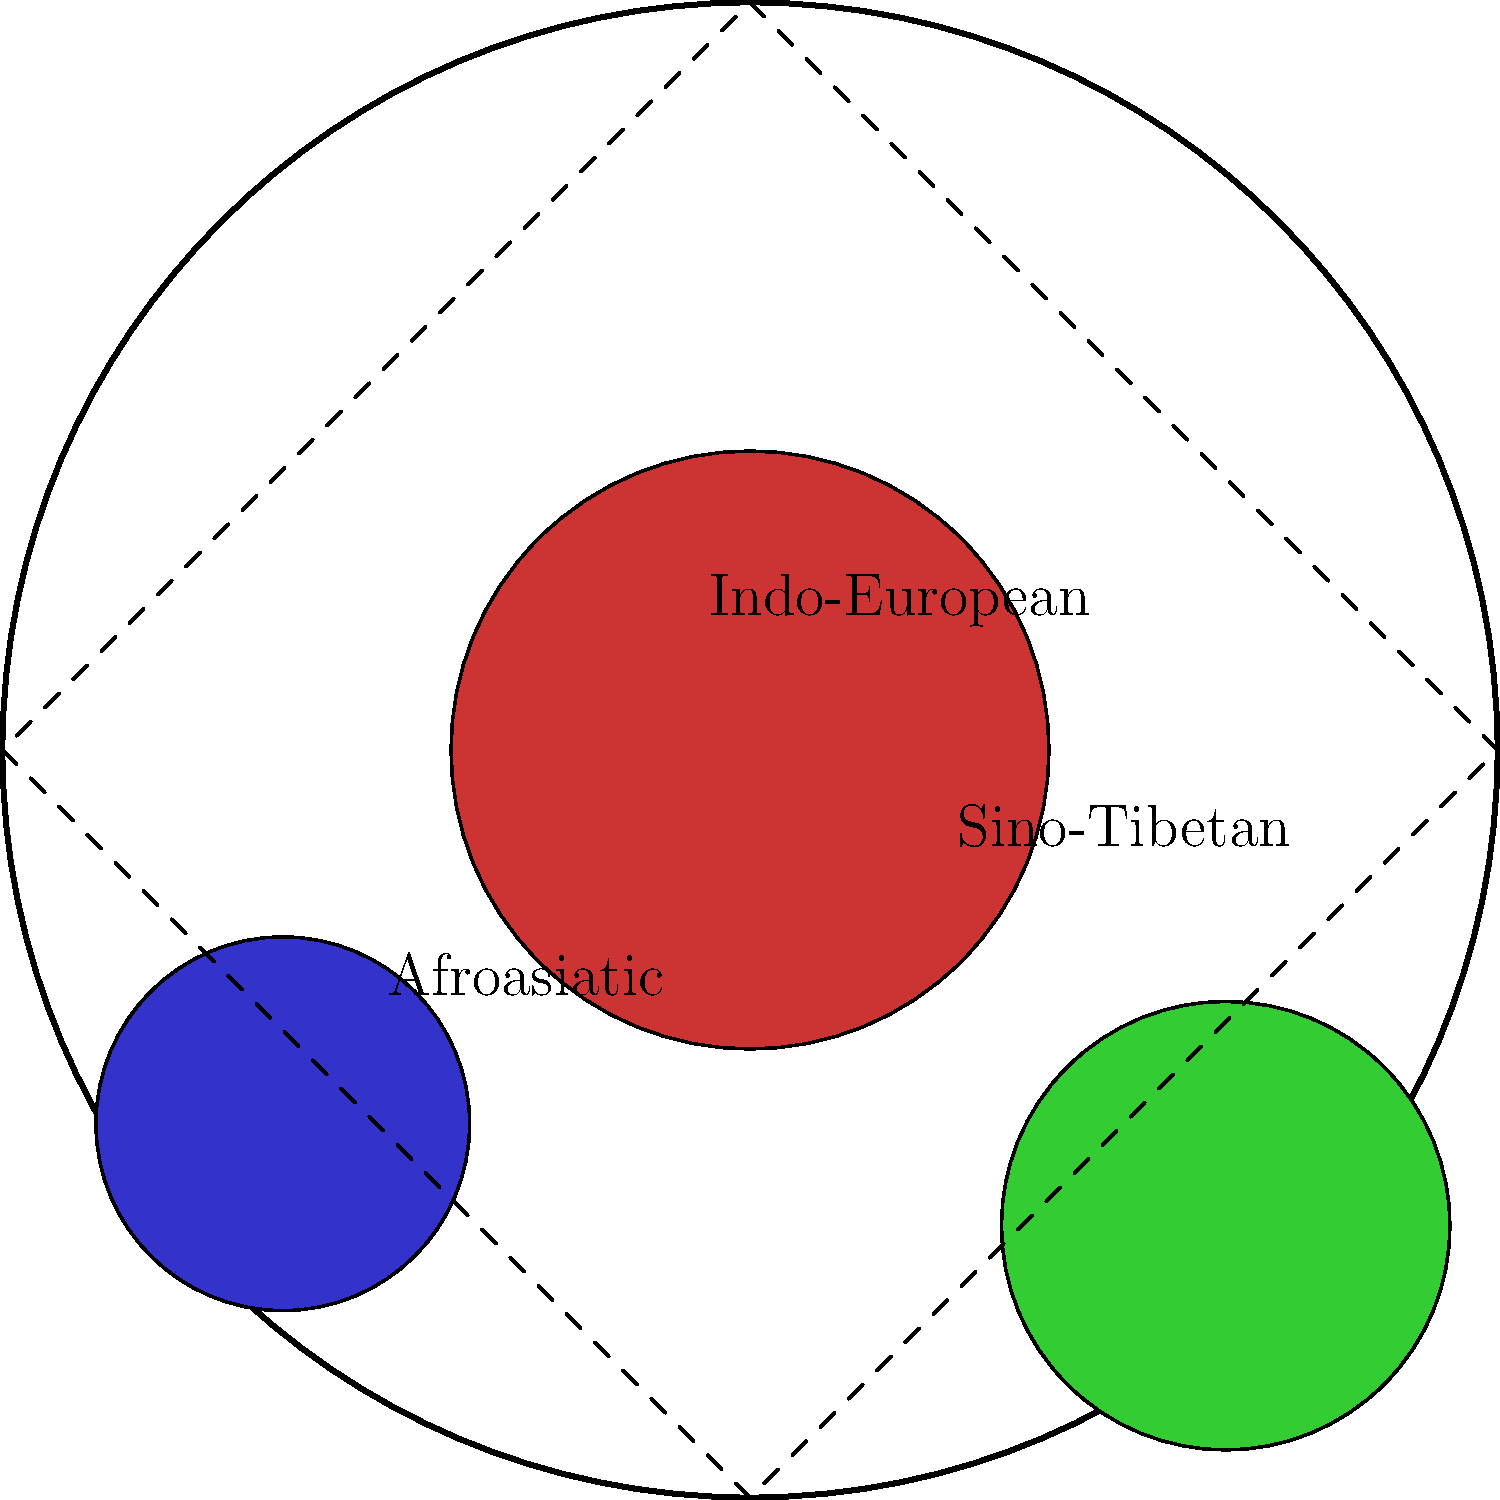A simplified world map is represented as a circle with a radius of 10 units. Three major language families are highlighted: Indo-European (red), Sino-Tibetan (green), and Afroasiatic (blue). If the map's scale is 1 unit = 1000 km, what is the approximate perimeter of this simplified world map in kilometers? To solve this problem, we need to follow these steps:

1) Recall the formula for the circumference (perimeter) of a circle:
   $$C = 2\pi r$$
   where $C$ is the circumference and $r$ is the radius.

2) We are given that the radius of the world map circle is 10 units.

3) Substitute this into our formula:
   $$C = 2\pi(10) = 20\pi$$

4) Calculate this value:
   $$20\pi \approx 62.83$$

5) Remember that each unit represents 1000 km. So we need to multiply our result by 1000:
   $$62.83 \times 1000 = 62,830$$

Therefore, the approximate perimeter of the simplified world map is 62,830 km.
Answer: 62,830 km 